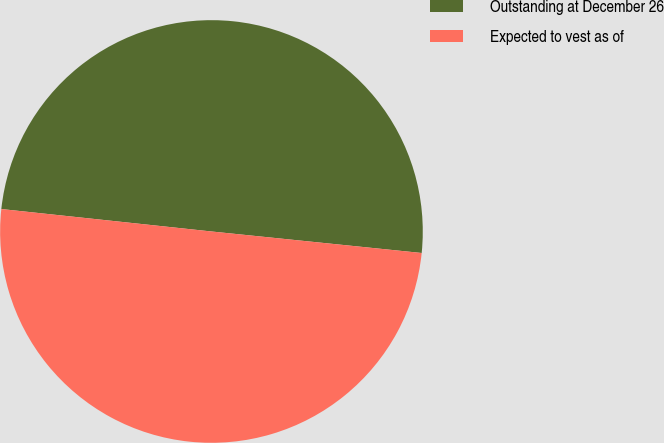<chart> <loc_0><loc_0><loc_500><loc_500><pie_chart><fcel>Outstanding at December 26<fcel>Expected to vest as of<nl><fcel>49.93%<fcel>50.07%<nl></chart> 